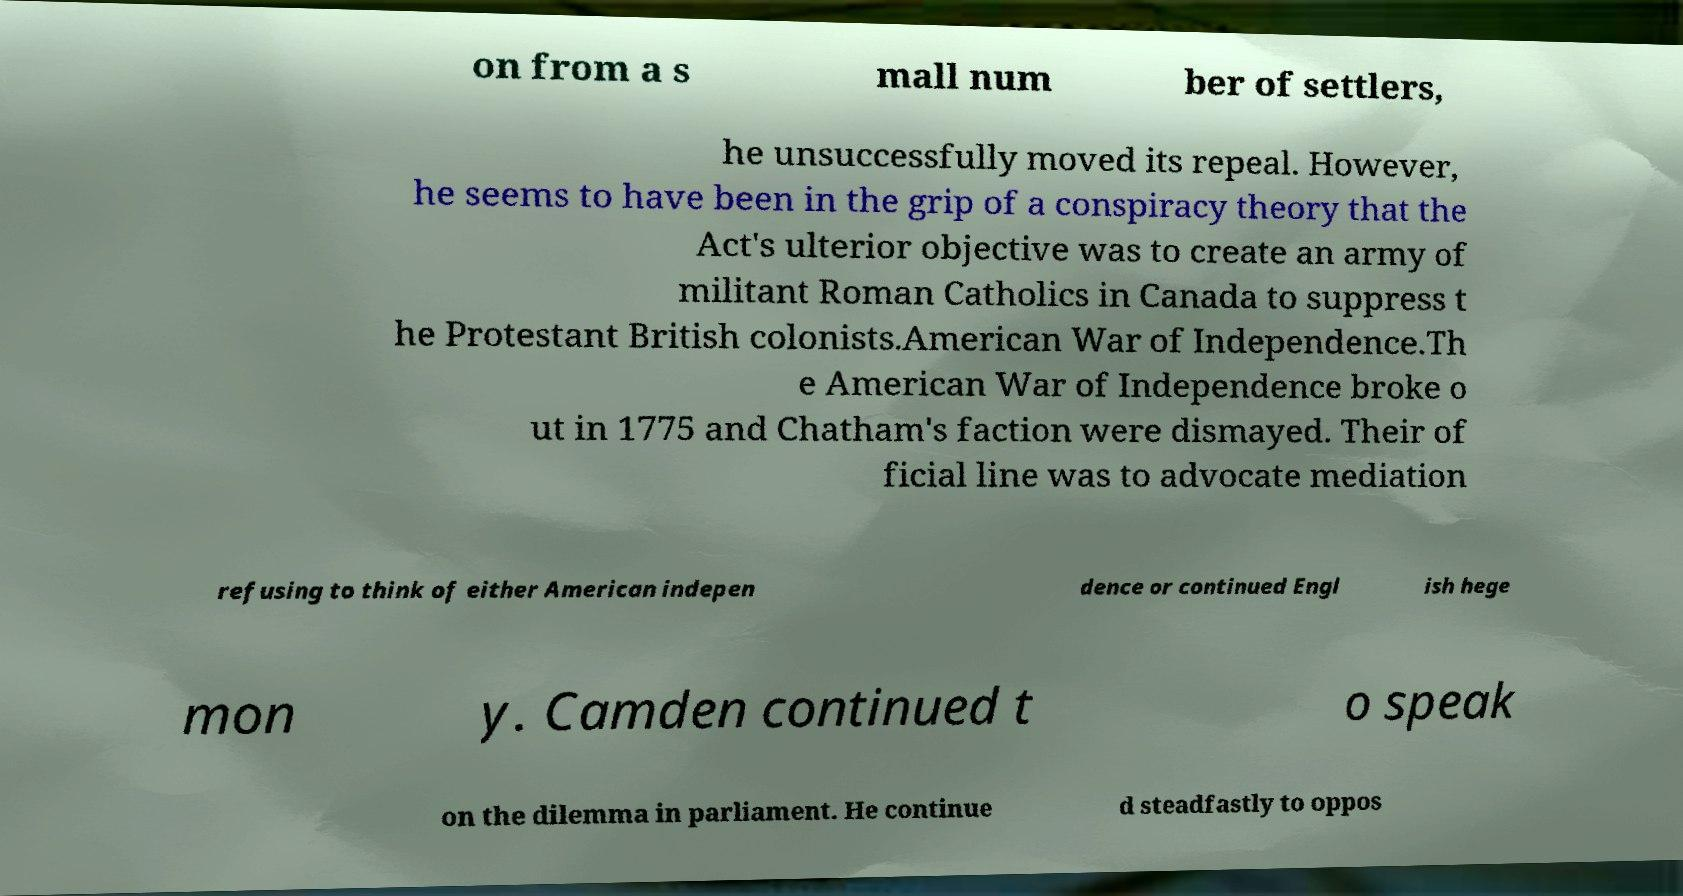Please read and relay the text visible in this image. What does it say? on from a s mall num ber of settlers, he unsuccessfully moved its repeal. However, he seems to have been in the grip of a conspiracy theory that the Act's ulterior objective was to create an army of militant Roman Catholics in Canada to suppress t he Protestant British colonists.American War of Independence.Th e American War of Independence broke o ut in 1775 and Chatham's faction were dismayed. Their of ficial line was to advocate mediation refusing to think of either American indepen dence or continued Engl ish hege mon y. Camden continued t o speak on the dilemma in parliament. He continue d steadfastly to oppos 